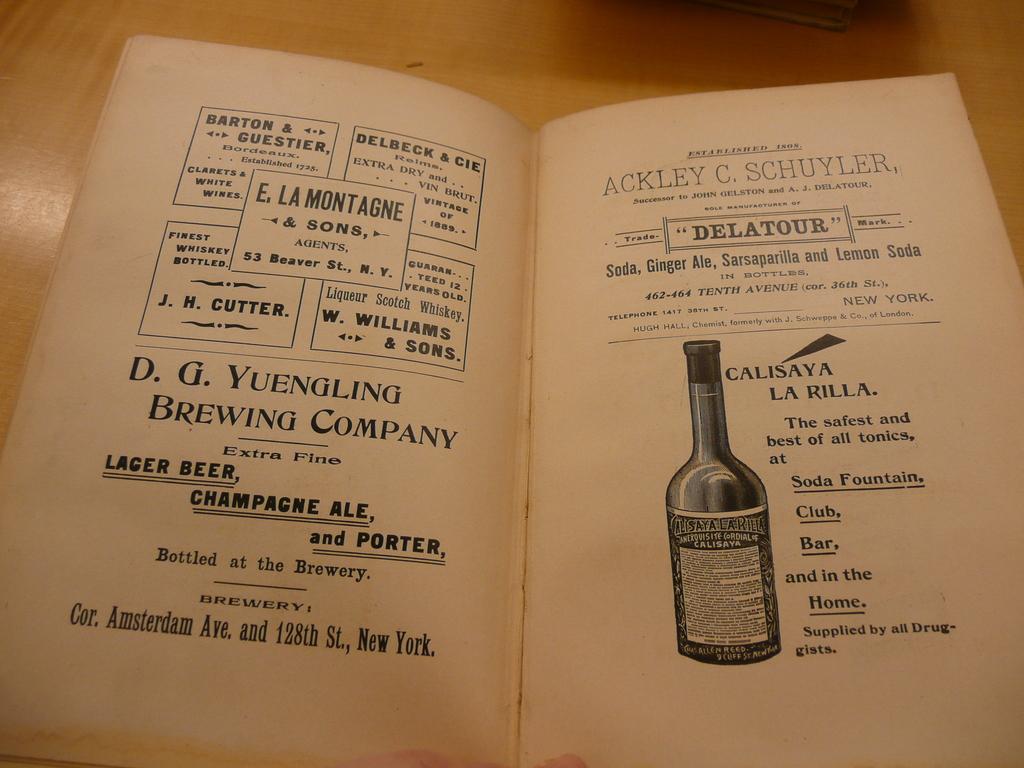What is the name of the brewing company?
Give a very brief answer. D.g. yuengling. What type of beer is this on the left underlined?
Make the answer very short. Lager beer. 